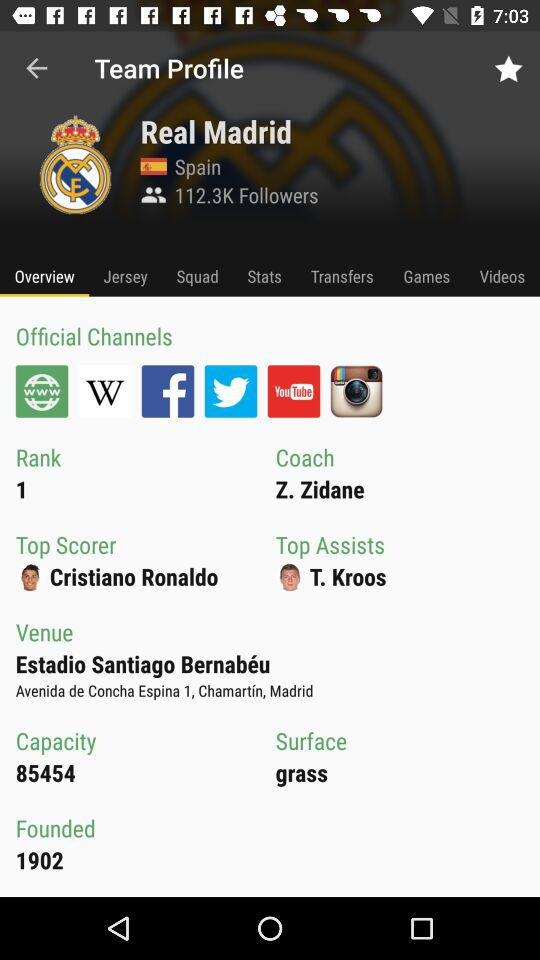Who is the top scorer? The top scorer is Cristiano Ronaldo. 